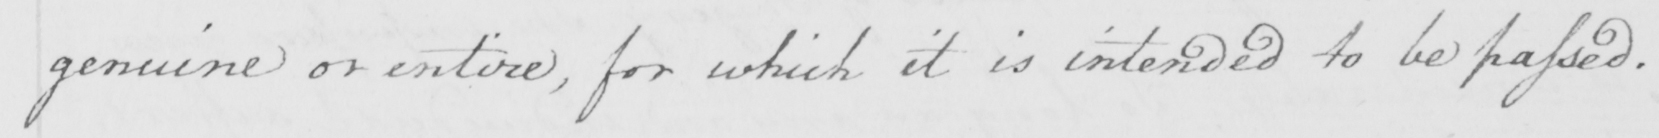Please provide the text content of this handwritten line. genuine or entire , for which it is intended to be passed . 